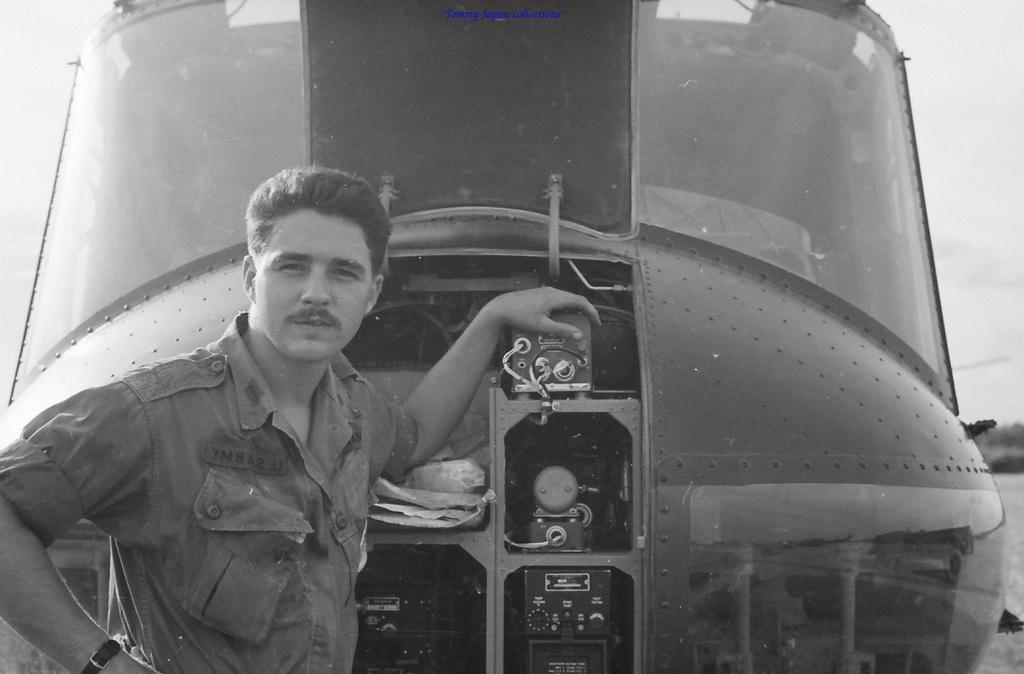What is the man doing in the image? The man is standing on the left side of the image with his hand on a helicopter. What is the main object in the middle of the image? There is a helicopter in the middle of the image. What is the man wearing in the image? The man is wearing a shirt in the image. What type of oil can be seen dripping from the helicopter in the image? There is no oil visible in the image, nor is there any indication of oil dripping from the helicopter. 